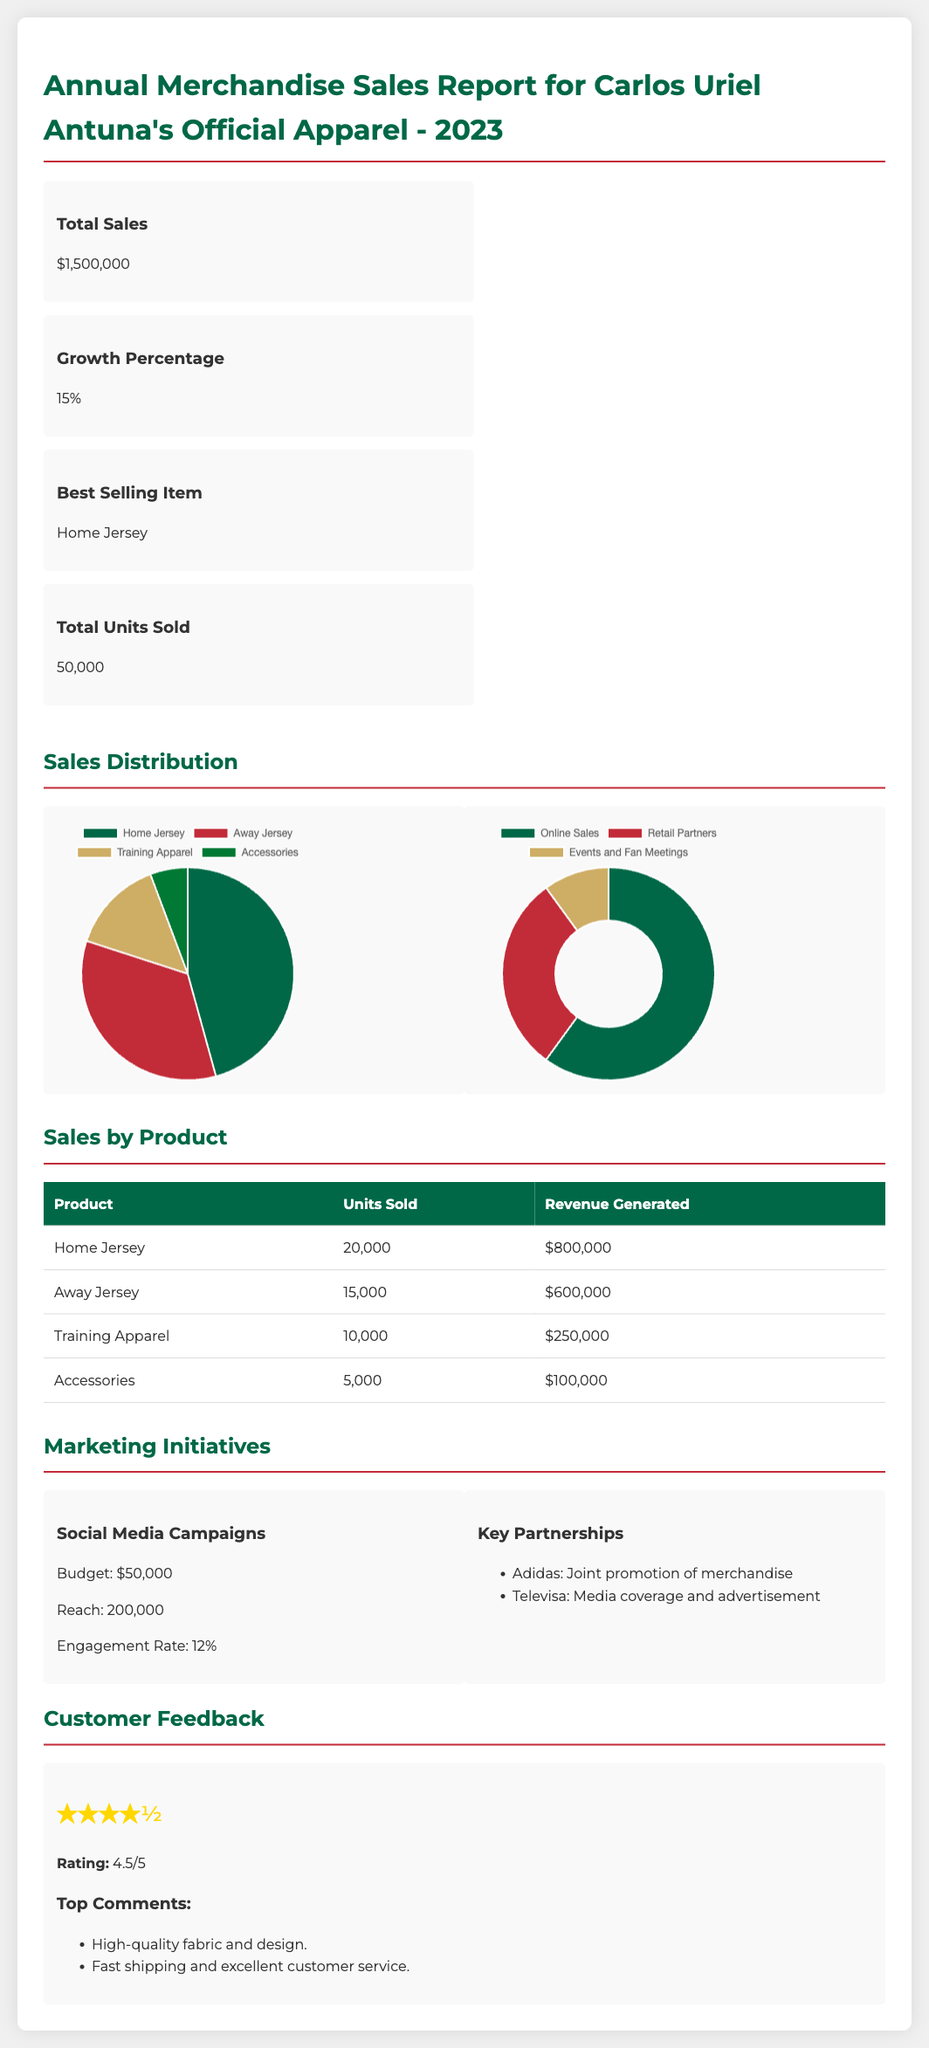What is the total sales amount? The total sales amount is stated in the summary section of the document as $1,500,000.
Answer: $1,500,000 What is the growth percentage? The growth percentage is detailed in the summary and is indicated as 15%.
Answer: 15% What is the best selling item? The best selling item is highlighted in the summary section, identified as the Home Jersey.
Answer: Home Jersey How many total units were sold? The total units sold can be found in the summary, which records 50,000 units.
Answer: 50,000 What revenue did the Away Jersey generate? The revenue generated by the Away Jersey is listed in the sales by product table as $600,000.
Answer: $600,000 What budget was allocated for social media campaigns? The allocated budget for social media campaigns is stated as $50,000 in the marketing initiatives section.
Answer: $50,000 What is the customer feedback rating? The customer feedback rating appears in the feedback section and is stated as 4.5 out of 5.
Answer: 4.5/5 Which channel had 60% of sales? The sales channel with 60% of sales is recorded as Online Sales in the sales by channel chart.
Answer: Online Sales How many units of Training Apparel were sold? The number of units sold for Training Apparel is recorded in the sales by product table as 10,000.
Answer: 10,000 